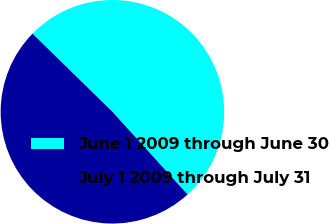Convert chart to OTSL. <chart><loc_0><loc_0><loc_500><loc_500><pie_chart><fcel>June 1 2009 through June 30<fcel>July 1 2009 through July 31<nl><fcel>50.94%<fcel>49.06%<nl></chart> 